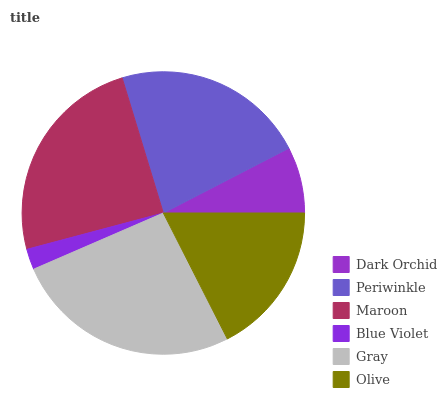Is Blue Violet the minimum?
Answer yes or no. Yes. Is Gray the maximum?
Answer yes or no. Yes. Is Periwinkle the minimum?
Answer yes or no. No. Is Periwinkle the maximum?
Answer yes or no. No. Is Periwinkle greater than Dark Orchid?
Answer yes or no. Yes. Is Dark Orchid less than Periwinkle?
Answer yes or no. Yes. Is Dark Orchid greater than Periwinkle?
Answer yes or no. No. Is Periwinkle less than Dark Orchid?
Answer yes or no. No. Is Periwinkle the high median?
Answer yes or no. Yes. Is Olive the low median?
Answer yes or no. Yes. Is Blue Violet the high median?
Answer yes or no. No. Is Dark Orchid the low median?
Answer yes or no. No. 